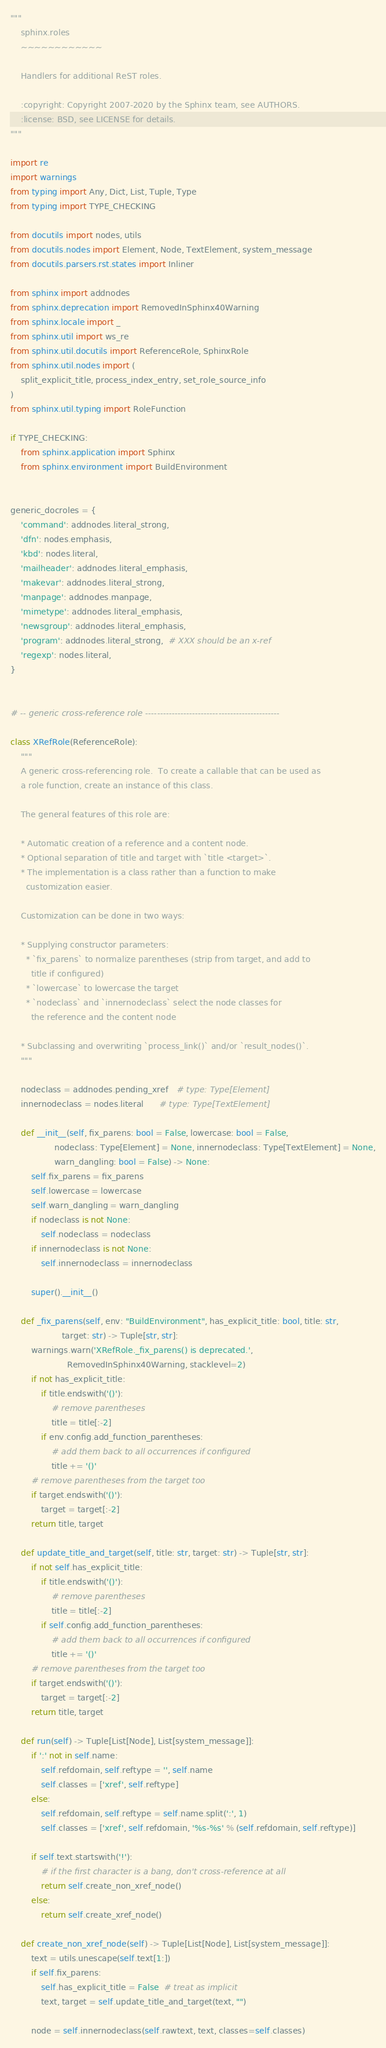Convert code to text. <code><loc_0><loc_0><loc_500><loc_500><_Python_>"""
    sphinx.roles
    ~~~~~~~~~~~~

    Handlers for additional ReST roles.

    :copyright: Copyright 2007-2020 by the Sphinx team, see AUTHORS.
    :license: BSD, see LICENSE for details.
"""

import re
import warnings
from typing import Any, Dict, List, Tuple, Type
from typing import TYPE_CHECKING

from docutils import nodes, utils
from docutils.nodes import Element, Node, TextElement, system_message
from docutils.parsers.rst.states import Inliner

from sphinx import addnodes
from sphinx.deprecation import RemovedInSphinx40Warning
from sphinx.locale import _
from sphinx.util import ws_re
from sphinx.util.docutils import ReferenceRole, SphinxRole
from sphinx.util.nodes import (
    split_explicit_title, process_index_entry, set_role_source_info
)
from sphinx.util.typing import RoleFunction

if TYPE_CHECKING:
    from sphinx.application import Sphinx
    from sphinx.environment import BuildEnvironment


generic_docroles = {
    'command': addnodes.literal_strong,
    'dfn': nodes.emphasis,
    'kbd': nodes.literal,
    'mailheader': addnodes.literal_emphasis,
    'makevar': addnodes.literal_strong,
    'manpage': addnodes.manpage,
    'mimetype': addnodes.literal_emphasis,
    'newsgroup': addnodes.literal_emphasis,
    'program': addnodes.literal_strong,  # XXX should be an x-ref
    'regexp': nodes.literal,
}


# -- generic cross-reference role ----------------------------------------------

class XRefRole(ReferenceRole):
    """
    A generic cross-referencing role.  To create a callable that can be used as
    a role function, create an instance of this class.

    The general features of this role are:

    * Automatic creation of a reference and a content node.
    * Optional separation of title and target with `title <target>`.
    * The implementation is a class rather than a function to make
      customization easier.

    Customization can be done in two ways:

    * Supplying constructor parameters:
      * `fix_parens` to normalize parentheses (strip from target, and add to
        title if configured)
      * `lowercase` to lowercase the target
      * `nodeclass` and `innernodeclass` select the node classes for
        the reference and the content node

    * Subclassing and overwriting `process_link()` and/or `result_nodes()`.
    """

    nodeclass = addnodes.pending_xref   # type: Type[Element]
    innernodeclass = nodes.literal      # type: Type[TextElement]

    def __init__(self, fix_parens: bool = False, lowercase: bool = False,
                 nodeclass: Type[Element] = None, innernodeclass: Type[TextElement] = None,
                 warn_dangling: bool = False) -> None:
        self.fix_parens = fix_parens
        self.lowercase = lowercase
        self.warn_dangling = warn_dangling
        if nodeclass is not None:
            self.nodeclass = nodeclass
        if innernodeclass is not None:
            self.innernodeclass = innernodeclass

        super().__init__()

    def _fix_parens(self, env: "BuildEnvironment", has_explicit_title: bool, title: str,
                    target: str) -> Tuple[str, str]:
        warnings.warn('XRefRole._fix_parens() is deprecated.',
                      RemovedInSphinx40Warning, stacklevel=2)
        if not has_explicit_title:
            if title.endswith('()'):
                # remove parentheses
                title = title[:-2]
            if env.config.add_function_parentheses:
                # add them back to all occurrences if configured
                title += '()'
        # remove parentheses from the target too
        if target.endswith('()'):
            target = target[:-2]
        return title, target

    def update_title_and_target(self, title: str, target: str) -> Tuple[str, str]:
        if not self.has_explicit_title:
            if title.endswith('()'):
                # remove parentheses
                title = title[:-2]
            if self.config.add_function_parentheses:
                # add them back to all occurrences if configured
                title += '()'
        # remove parentheses from the target too
        if target.endswith('()'):
            target = target[:-2]
        return title, target

    def run(self) -> Tuple[List[Node], List[system_message]]:
        if ':' not in self.name:
            self.refdomain, self.reftype = '', self.name
            self.classes = ['xref', self.reftype]
        else:
            self.refdomain, self.reftype = self.name.split(':', 1)
            self.classes = ['xref', self.refdomain, '%s-%s' % (self.refdomain, self.reftype)]

        if self.text.startswith('!'):
            # if the first character is a bang, don't cross-reference at all
            return self.create_non_xref_node()
        else:
            return self.create_xref_node()

    def create_non_xref_node(self) -> Tuple[List[Node], List[system_message]]:
        text = utils.unescape(self.text[1:])
        if self.fix_parens:
            self.has_explicit_title = False  # treat as implicit
            text, target = self.update_title_and_target(text, "")

        node = self.innernodeclass(self.rawtext, text, classes=self.classes)</code> 